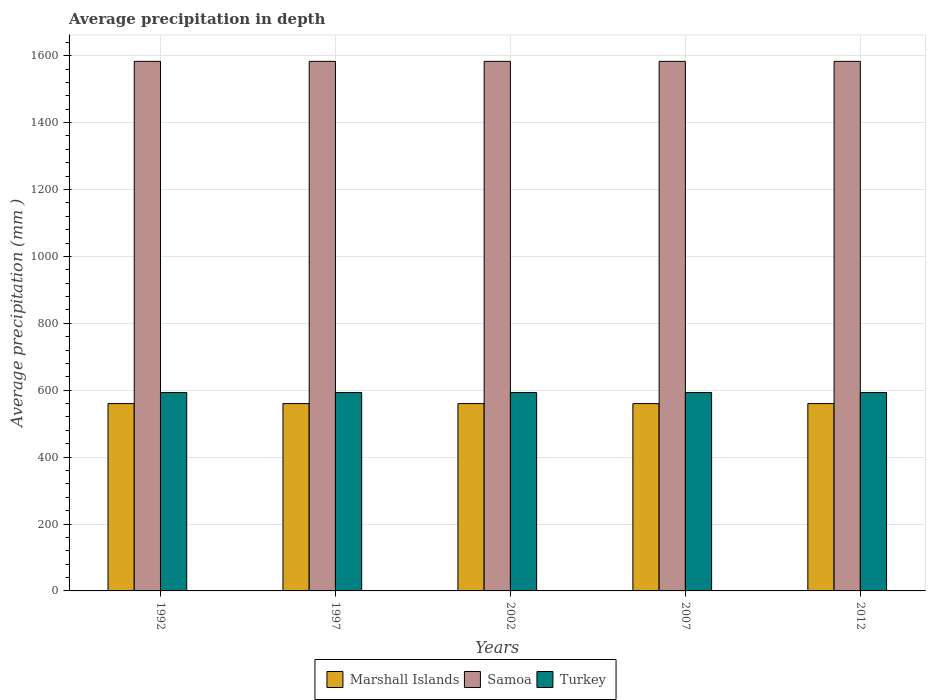Are the number of bars per tick equal to the number of legend labels?
Provide a succinct answer. Yes. Are the number of bars on each tick of the X-axis equal?
Your answer should be compact. Yes. What is the average precipitation in Turkey in 1992?
Make the answer very short. 593. Across all years, what is the maximum average precipitation in Samoa?
Ensure brevity in your answer.  1583. Across all years, what is the minimum average precipitation in Marshall Islands?
Ensure brevity in your answer.  560. In which year was the average precipitation in Marshall Islands maximum?
Keep it short and to the point. 1992. In which year was the average precipitation in Turkey minimum?
Keep it short and to the point. 1992. What is the total average precipitation in Samoa in the graph?
Your answer should be compact. 7915. What is the difference between the average precipitation in Marshall Islands in 2007 and the average precipitation in Samoa in 1997?
Provide a succinct answer. -1023. What is the average average precipitation in Marshall Islands per year?
Keep it short and to the point. 560. In the year 1992, what is the difference between the average precipitation in Samoa and average precipitation in Turkey?
Keep it short and to the point. 990. What is the difference between the highest and the lowest average precipitation in Samoa?
Your answer should be compact. 0. In how many years, is the average precipitation in Samoa greater than the average average precipitation in Samoa taken over all years?
Provide a succinct answer. 0. What does the 2nd bar from the left in 1997 represents?
Ensure brevity in your answer.  Samoa. Is it the case that in every year, the sum of the average precipitation in Turkey and average precipitation in Marshall Islands is greater than the average precipitation in Samoa?
Make the answer very short. No. What is the difference between two consecutive major ticks on the Y-axis?
Your answer should be very brief. 200. Does the graph contain any zero values?
Your answer should be compact. No. Does the graph contain grids?
Provide a short and direct response. Yes. Where does the legend appear in the graph?
Ensure brevity in your answer.  Bottom center. How are the legend labels stacked?
Provide a succinct answer. Horizontal. What is the title of the graph?
Offer a terse response. Average precipitation in depth. What is the label or title of the Y-axis?
Make the answer very short. Average precipitation (mm ). What is the Average precipitation (mm ) in Marshall Islands in 1992?
Keep it short and to the point. 560. What is the Average precipitation (mm ) in Samoa in 1992?
Your answer should be very brief. 1583. What is the Average precipitation (mm ) of Turkey in 1992?
Your response must be concise. 593. What is the Average precipitation (mm ) in Marshall Islands in 1997?
Offer a terse response. 560. What is the Average precipitation (mm ) of Samoa in 1997?
Give a very brief answer. 1583. What is the Average precipitation (mm ) of Turkey in 1997?
Offer a terse response. 593. What is the Average precipitation (mm ) in Marshall Islands in 2002?
Give a very brief answer. 560. What is the Average precipitation (mm ) of Samoa in 2002?
Provide a short and direct response. 1583. What is the Average precipitation (mm ) in Turkey in 2002?
Offer a very short reply. 593. What is the Average precipitation (mm ) of Marshall Islands in 2007?
Make the answer very short. 560. What is the Average precipitation (mm ) in Samoa in 2007?
Keep it short and to the point. 1583. What is the Average precipitation (mm ) of Turkey in 2007?
Make the answer very short. 593. What is the Average precipitation (mm ) in Marshall Islands in 2012?
Make the answer very short. 560. What is the Average precipitation (mm ) of Samoa in 2012?
Give a very brief answer. 1583. What is the Average precipitation (mm ) in Turkey in 2012?
Offer a terse response. 593. Across all years, what is the maximum Average precipitation (mm ) in Marshall Islands?
Provide a succinct answer. 560. Across all years, what is the maximum Average precipitation (mm ) of Samoa?
Your response must be concise. 1583. Across all years, what is the maximum Average precipitation (mm ) of Turkey?
Offer a terse response. 593. Across all years, what is the minimum Average precipitation (mm ) in Marshall Islands?
Your answer should be compact. 560. Across all years, what is the minimum Average precipitation (mm ) of Samoa?
Ensure brevity in your answer.  1583. Across all years, what is the minimum Average precipitation (mm ) of Turkey?
Offer a very short reply. 593. What is the total Average precipitation (mm ) in Marshall Islands in the graph?
Your answer should be very brief. 2800. What is the total Average precipitation (mm ) in Samoa in the graph?
Ensure brevity in your answer.  7915. What is the total Average precipitation (mm ) of Turkey in the graph?
Your answer should be compact. 2965. What is the difference between the Average precipitation (mm ) of Turkey in 1992 and that in 1997?
Ensure brevity in your answer.  0. What is the difference between the Average precipitation (mm ) in Marshall Islands in 1992 and that in 2002?
Make the answer very short. 0. What is the difference between the Average precipitation (mm ) in Turkey in 1992 and that in 2002?
Offer a terse response. 0. What is the difference between the Average precipitation (mm ) in Marshall Islands in 1992 and that in 2007?
Keep it short and to the point. 0. What is the difference between the Average precipitation (mm ) of Samoa in 1992 and that in 2007?
Provide a short and direct response. 0. What is the difference between the Average precipitation (mm ) of Samoa in 1992 and that in 2012?
Provide a succinct answer. 0. What is the difference between the Average precipitation (mm ) of Samoa in 1997 and that in 2002?
Offer a terse response. 0. What is the difference between the Average precipitation (mm ) in Turkey in 1997 and that in 2002?
Make the answer very short. 0. What is the difference between the Average precipitation (mm ) in Marshall Islands in 1997 and that in 2007?
Your response must be concise. 0. What is the difference between the Average precipitation (mm ) of Turkey in 1997 and that in 2007?
Ensure brevity in your answer.  0. What is the difference between the Average precipitation (mm ) in Samoa in 2002 and that in 2012?
Give a very brief answer. 0. What is the difference between the Average precipitation (mm ) in Turkey in 2002 and that in 2012?
Your response must be concise. 0. What is the difference between the Average precipitation (mm ) of Marshall Islands in 2007 and that in 2012?
Your answer should be compact. 0. What is the difference between the Average precipitation (mm ) of Samoa in 2007 and that in 2012?
Offer a very short reply. 0. What is the difference between the Average precipitation (mm ) of Turkey in 2007 and that in 2012?
Your answer should be very brief. 0. What is the difference between the Average precipitation (mm ) of Marshall Islands in 1992 and the Average precipitation (mm ) of Samoa in 1997?
Give a very brief answer. -1023. What is the difference between the Average precipitation (mm ) in Marshall Islands in 1992 and the Average precipitation (mm ) in Turkey in 1997?
Ensure brevity in your answer.  -33. What is the difference between the Average precipitation (mm ) of Samoa in 1992 and the Average precipitation (mm ) of Turkey in 1997?
Make the answer very short. 990. What is the difference between the Average precipitation (mm ) in Marshall Islands in 1992 and the Average precipitation (mm ) in Samoa in 2002?
Provide a short and direct response. -1023. What is the difference between the Average precipitation (mm ) of Marshall Islands in 1992 and the Average precipitation (mm ) of Turkey in 2002?
Give a very brief answer. -33. What is the difference between the Average precipitation (mm ) of Samoa in 1992 and the Average precipitation (mm ) of Turkey in 2002?
Offer a terse response. 990. What is the difference between the Average precipitation (mm ) in Marshall Islands in 1992 and the Average precipitation (mm ) in Samoa in 2007?
Offer a very short reply. -1023. What is the difference between the Average precipitation (mm ) in Marshall Islands in 1992 and the Average precipitation (mm ) in Turkey in 2007?
Your response must be concise. -33. What is the difference between the Average precipitation (mm ) in Samoa in 1992 and the Average precipitation (mm ) in Turkey in 2007?
Your response must be concise. 990. What is the difference between the Average precipitation (mm ) in Marshall Islands in 1992 and the Average precipitation (mm ) in Samoa in 2012?
Ensure brevity in your answer.  -1023. What is the difference between the Average precipitation (mm ) in Marshall Islands in 1992 and the Average precipitation (mm ) in Turkey in 2012?
Provide a short and direct response. -33. What is the difference between the Average precipitation (mm ) of Samoa in 1992 and the Average precipitation (mm ) of Turkey in 2012?
Offer a very short reply. 990. What is the difference between the Average precipitation (mm ) in Marshall Islands in 1997 and the Average precipitation (mm ) in Samoa in 2002?
Provide a short and direct response. -1023. What is the difference between the Average precipitation (mm ) in Marshall Islands in 1997 and the Average precipitation (mm ) in Turkey in 2002?
Provide a short and direct response. -33. What is the difference between the Average precipitation (mm ) of Samoa in 1997 and the Average precipitation (mm ) of Turkey in 2002?
Provide a succinct answer. 990. What is the difference between the Average precipitation (mm ) in Marshall Islands in 1997 and the Average precipitation (mm ) in Samoa in 2007?
Provide a short and direct response. -1023. What is the difference between the Average precipitation (mm ) in Marshall Islands in 1997 and the Average precipitation (mm ) in Turkey in 2007?
Offer a terse response. -33. What is the difference between the Average precipitation (mm ) of Samoa in 1997 and the Average precipitation (mm ) of Turkey in 2007?
Your response must be concise. 990. What is the difference between the Average precipitation (mm ) in Marshall Islands in 1997 and the Average precipitation (mm ) in Samoa in 2012?
Give a very brief answer. -1023. What is the difference between the Average precipitation (mm ) of Marshall Islands in 1997 and the Average precipitation (mm ) of Turkey in 2012?
Keep it short and to the point. -33. What is the difference between the Average precipitation (mm ) of Samoa in 1997 and the Average precipitation (mm ) of Turkey in 2012?
Your answer should be very brief. 990. What is the difference between the Average precipitation (mm ) in Marshall Islands in 2002 and the Average precipitation (mm ) in Samoa in 2007?
Give a very brief answer. -1023. What is the difference between the Average precipitation (mm ) in Marshall Islands in 2002 and the Average precipitation (mm ) in Turkey in 2007?
Ensure brevity in your answer.  -33. What is the difference between the Average precipitation (mm ) in Samoa in 2002 and the Average precipitation (mm ) in Turkey in 2007?
Ensure brevity in your answer.  990. What is the difference between the Average precipitation (mm ) in Marshall Islands in 2002 and the Average precipitation (mm ) in Samoa in 2012?
Your answer should be compact. -1023. What is the difference between the Average precipitation (mm ) of Marshall Islands in 2002 and the Average precipitation (mm ) of Turkey in 2012?
Ensure brevity in your answer.  -33. What is the difference between the Average precipitation (mm ) of Samoa in 2002 and the Average precipitation (mm ) of Turkey in 2012?
Provide a short and direct response. 990. What is the difference between the Average precipitation (mm ) of Marshall Islands in 2007 and the Average precipitation (mm ) of Samoa in 2012?
Provide a succinct answer. -1023. What is the difference between the Average precipitation (mm ) in Marshall Islands in 2007 and the Average precipitation (mm ) in Turkey in 2012?
Make the answer very short. -33. What is the difference between the Average precipitation (mm ) of Samoa in 2007 and the Average precipitation (mm ) of Turkey in 2012?
Keep it short and to the point. 990. What is the average Average precipitation (mm ) of Marshall Islands per year?
Your answer should be compact. 560. What is the average Average precipitation (mm ) in Samoa per year?
Make the answer very short. 1583. What is the average Average precipitation (mm ) of Turkey per year?
Ensure brevity in your answer.  593. In the year 1992, what is the difference between the Average precipitation (mm ) in Marshall Islands and Average precipitation (mm ) in Samoa?
Ensure brevity in your answer.  -1023. In the year 1992, what is the difference between the Average precipitation (mm ) in Marshall Islands and Average precipitation (mm ) in Turkey?
Make the answer very short. -33. In the year 1992, what is the difference between the Average precipitation (mm ) in Samoa and Average precipitation (mm ) in Turkey?
Ensure brevity in your answer.  990. In the year 1997, what is the difference between the Average precipitation (mm ) in Marshall Islands and Average precipitation (mm ) in Samoa?
Your answer should be very brief. -1023. In the year 1997, what is the difference between the Average precipitation (mm ) in Marshall Islands and Average precipitation (mm ) in Turkey?
Your answer should be very brief. -33. In the year 1997, what is the difference between the Average precipitation (mm ) of Samoa and Average precipitation (mm ) of Turkey?
Make the answer very short. 990. In the year 2002, what is the difference between the Average precipitation (mm ) of Marshall Islands and Average precipitation (mm ) of Samoa?
Keep it short and to the point. -1023. In the year 2002, what is the difference between the Average precipitation (mm ) in Marshall Islands and Average precipitation (mm ) in Turkey?
Give a very brief answer. -33. In the year 2002, what is the difference between the Average precipitation (mm ) of Samoa and Average precipitation (mm ) of Turkey?
Provide a short and direct response. 990. In the year 2007, what is the difference between the Average precipitation (mm ) of Marshall Islands and Average precipitation (mm ) of Samoa?
Your response must be concise. -1023. In the year 2007, what is the difference between the Average precipitation (mm ) of Marshall Islands and Average precipitation (mm ) of Turkey?
Your answer should be compact. -33. In the year 2007, what is the difference between the Average precipitation (mm ) of Samoa and Average precipitation (mm ) of Turkey?
Make the answer very short. 990. In the year 2012, what is the difference between the Average precipitation (mm ) in Marshall Islands and Average precipitation (mm ) in Samoa?
Give a very brief answer. -1023. In the year 2012, what is the difference between the Average precipitation (mm ) in Marshall Islands and Average precipitation (mm ) in Turkey?
Provide a succinct answer. -33. In the year 2012, what is the difference between the Average precipitation (mm ) of Samoa and Average precipitation (mm ) of Turkey?
Your answer should be compact. 990. What is the ratio of the Average precipitation (mm ) of Marshall Islands in 1992 to that in 1997?
Your response must be concise. 1. What is the ratio of the Average precipitation (mm ) of Turkey in 1992 to that in 1997?
Keep it short and to the point. 1. What is the ratio of the Average precipitation (mm ) of Marshall Islands in 1992 to that in 2002?
Your answer should be very brief. 1. What is the ratio of the Average precipitation (mm ) of Samoa in 1992 to that in 2002?
Offer a terse response. 1. What is the ratio of the Average precipitation (mm ) of Turkey in 1992 to that in 2002?
Your answer should be very brief. 1. What is the ratio of the Average precipitation (mm ) of Marshall Islands in 1992 to that in 2007?
Offer a terse response. 1. What is the ratio of the Average precipitation (mm ) of Turkey in 1992 to that in 2007?
Your response must be concise. 1. What is the ratio of the Average precipitation (mm ) in Marshall Islands in 1992 to that in 2012?
Offer a terse response. 1. What is the ratio of the Average precipitation (mm ) of Marshall Islands in 1997 to that in 2002?
Ensure brevity in your answer.  1. What is the ratio of the Average precipitation (mm ) in Samoa in 1997 to that in 2002?
Provide a succinct answer. 1. What is the ratio of the Average precipitation (mm ) of Turkey in 1997 to that in 2002?
Provide a short and direct response. 1. What is the ratio of the Average precipitation (mm ) in Marshall Islands in 1997 to that in 2007?
Your answer should be very brief. 1. What is the ratio of the Average precipitation (mm ) in Samoa in 1997 to that in 2012?
Offer a very short reply. 1. What is the ratio of the Average precipitation (mm ) in Turkey in 1997 to that in 2012?
Give a very brief answer. 1. What is the ratio of the Average precipitation (mm ) of Marshall Islands in 2002 to that in 2007?
Provide a succinct answer. 1. What is the ratio of the Average precipitation (mm ) of Samoa in 2002 to that in 2007?
Your answer should be very brief. 1. What is the ratio of the Average precipitation (mm ) in Marshall Islands in 2002 to that in 2012?
Make the answer very short. 1. What is the ratio of the Average precipitation (mm ) in Turkey in 2002 to that in 2012?
Give a very brief answer. 1. What is the ratio of the Average precipitation (mm ) in Turkey in 2007 to that in 2012?
Provide a short and direct response. 1. What is the difference between the highest and the second highest Average precipitation (mm ) in Samoa?
Ensure brevity in your answer.  0. What is the difference between the highest and the lowest Average precipitation (mm ) of Marshall Islands?
Offer a terse response. 0. What is the difference between the highest and the lowest Average precipitation (mm ) in Turkey?
Offer a very short reply. 0. 